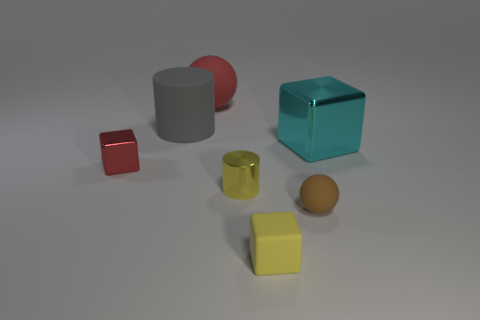Subtract all shiny blocks. How many blocks are left? 1 Add 2 tiny matte balls. How many objects exist? 9 Subtract all yellow cubes. How many cubes are left? 2 Subtract 1 cylinders. How many cylinders are left? 1 Subtract all cylinders. How many objects are left? 5 Add 4 brown rubber things. How many brown rubber things are left? 5 Add 5 gray cylinders. How many gray cylinders exist? 6 Subtract 0 blue cubes. How many objects are left? 7 Subtract all yellow blocks. Subtract all gray spheres. How many blocks are left? 2 Subtract all red shiny spheres. Subtract all big cyan metallic objects. How many objects are left? 6 